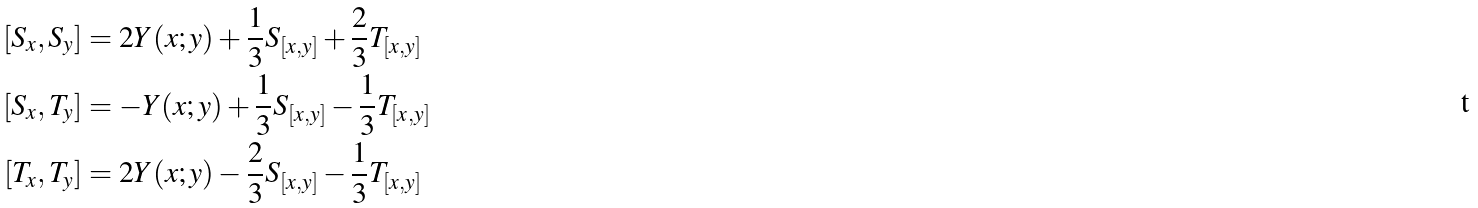<formula> <loc_0><loc_0><loc_500><loc_500>[ S _ { x } , S _ { y } ] & = 2 Y ( x ; y ) + \frac { 1 } { 3 } S _ { [ x , y ] } + \frac { 2 } { 3 } T _ { [ x , y ] } \\ [ S _ { x } , T _ { y } ] & = - Y ( x ; y ) + \frac { 1 } { 3 } S _ { [ x , y ] } - \frac { 1 } { 3 } T _ { [ x , y ] } \\ [ T _ { x } , T _ { y } ] & = 2 Y ( x ; y ) - \frac { 2 } { 3 } S _ { [ x , y ] } - \frac { 1 } { 3 } T _ { [ x , y ] }</formula> 